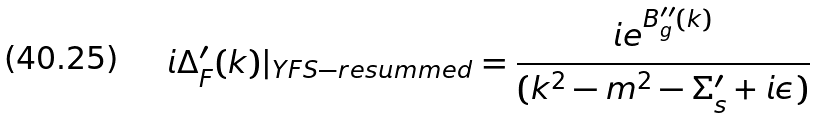<formula> <loc_0><loc_0><loc_500><loc_500>i \Delta ^ { \prime } _ { F } ( k ) | _ { Y F S - r e s u m m e d } = \frac { i e ^ { B ^ { \prime \prime } _ { g } ( k ) } } { ( k ^ { 2 } - m ^ { 2 } - \Sigma ^ { \prime } _ { s } + i \epsilon ) }</formula> 